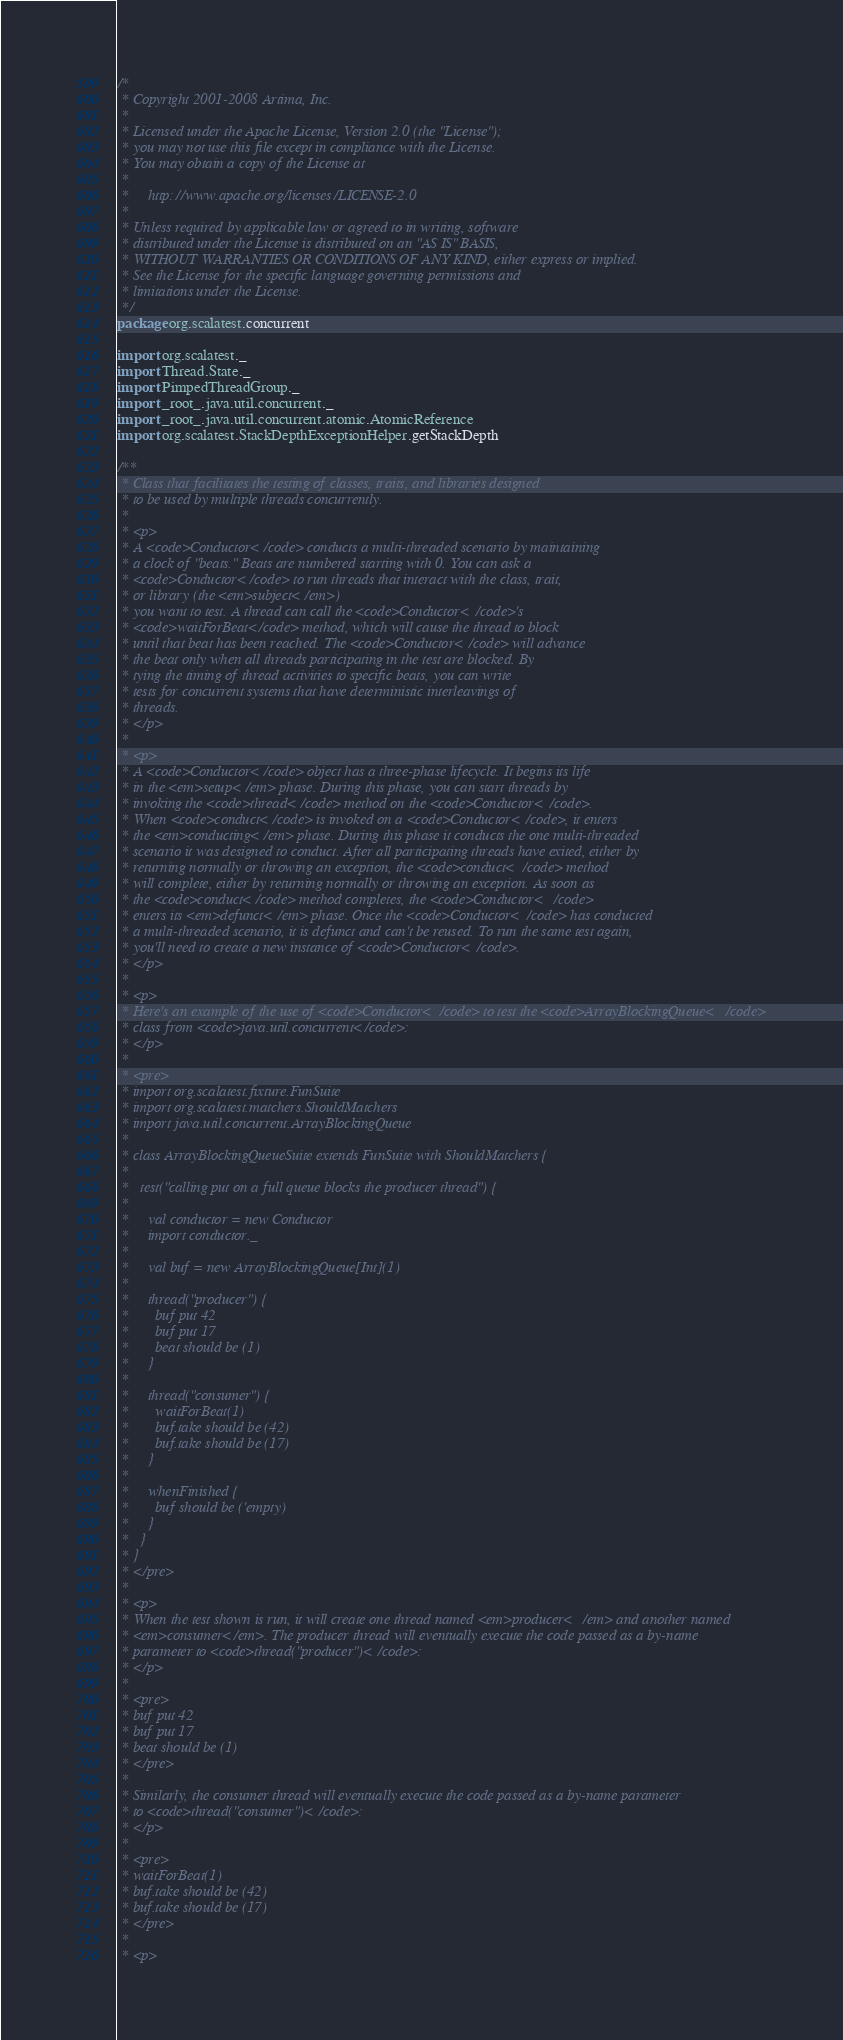Convert code to text. <code><loc_0><loc_0><loc_500><loc_500><_Scala_>/*
 * Copyright 2001-2008 Artima, Inc.
 *
 * Licensed under the Apache License, Version 2.0 (the "License");
 * you may not use this file except in compliance with the License.
 * You may obtain a copy of the License at
 *
 *     http://www.apache.org/licenses/LICENSE-2.0
 *
 * Unless required by applicable law or agreed to in writing, software
 * distributed under the License is distributed on an "AS IS" BASIS,
 * WITHOUT WARRANTIES OR CONDITIONS OF ANY KIND, either express or implied.
 * See the License for the specific language governing permissions and
 * limitations under the License.
 */
package org.scalatest.concurrent

import org.scalatest._
import Thread.State._
import PimpedThreadGroup._
import _root_.java.util.concurrent._
import _root_.java.util.concurrent.atomic.AtomicReference
import org.scalatest.StackDepthExceptionHelper.getStackDepth

/**
 * Class that facilitates the testing of classes, traits, and libraries designed
 * to be used by multiple threads concurrently.
 *
 * <p>
 * A <code>Conductor</code> conducts a multi-threaded scenario by maintaining
 * a clock of "beats." Beats are numbered starting with 0. You can ask a
 * <code>Conductor</code> to run threads that interact with the class, trait,
 * or library (the <em>subject</em>)
 * you want to test. A thread can call the <code>Conductor</code>'s
 * <code>waitForBeat</code> method, which will cause the thread to block
 * until that beat has been reached. The <code>Conductor</code> will advance
 * the beat only when all threads participating in the test are blocked. By
 * tying the timing of thread activities to specific beats, you can write
 * tests for concurrent systems that have deterministic interleavings of
 * threads.
 * </p>
 *
 * <p>
 * A <code>Conductor</code> object has a three-phase lifecycle. It begins its life
 * in the <em>setup</em> phase. During this phase, you can start threads by
 * invoking the <code>thread</code> method on the <code>Conductor</code>.
 * When <code>conduct</code> is invoked on a <code>Conductor</code>, it enters
 * the <em>conducting</em> phase. During this phase it conducts the one multi-threaded
 * scenario it was designed to conduct. After all participating threads have exited, either by
 * returning normally or throwing an exception, the <code>conduct</code> method
 * will complete, either by returning normally or throwing an exception. As soon as
 * the <code>conduct</code> method completes, the <code>Conductor</code>
 * enters its <em>defunct</em> phase. Once the <code>Conductor</code> has conducted
 * a multi-threaded scenario, it is defunct and can't be reused. To run the same test again,
 * you'll need to create a new instance of <code>Conductor</code>.
 * </p>
 *
 * <p>
 * Here's an example of the use of <code>Conductor</code> to test the <code>ArrayBlockingQueue</code>
 * class from <code>java.util.concurrent</code>:
 * </p>
 *
 * <pre>
 * import org.scalatest.fixture.FunSuite
 * import org.scalatest.matchers.ShouldMatchers
 * import java.util.concurrent.ArrayBlockingQueue
 *
 * class ArrayBlockingQueueSuite extends FunSuite with ShouldMatchers {
 * 
 *   test("calling put on a full queue blocks the producer thread") {
 *
 *     val conductor = new Conductor
 *     import conductor._
 *
 *     val buf = new ArrayBlockingQueue[Int](1)
 * 
 *     thread("producer") {
 *       buf put 42
 *       buf put 17
 *       beat should be (1)
 *     }
 * 
 *     thread("consumer") {
 *       waitForBeat(1)
 *       buf.take should be (42)
 *       buf.take should be (17)
 *     }
 * 
 *     whenFinished {
 *       buf should be ('empty)
 *     }
 *   }
 * }
 * </pre>
 *
 * <p>
 * When the test shown is run, it will create one thread named <em>producer</em> and another named
 * <em>consumer</em>. The producer thread will eventually execute the code passed as a by-name
 * parameter to <code>thread("producer")</code>:
 * </p>
 *
 * <pre>
 * buf put 42
 * buf put 17
 * beat should be (1)
 * </pre>
 *
 * Similarly, the consumer thread will eventually execute the code passed as a by-name parameter
 * to <code>thread("consumer")</code>:
 * </p>
 *
 * <pre>
 * waitForBeat(1)
 * buf.take should be (42)
 * buf.take should be (17)
 * </pre>
 *
 * <p></code> 